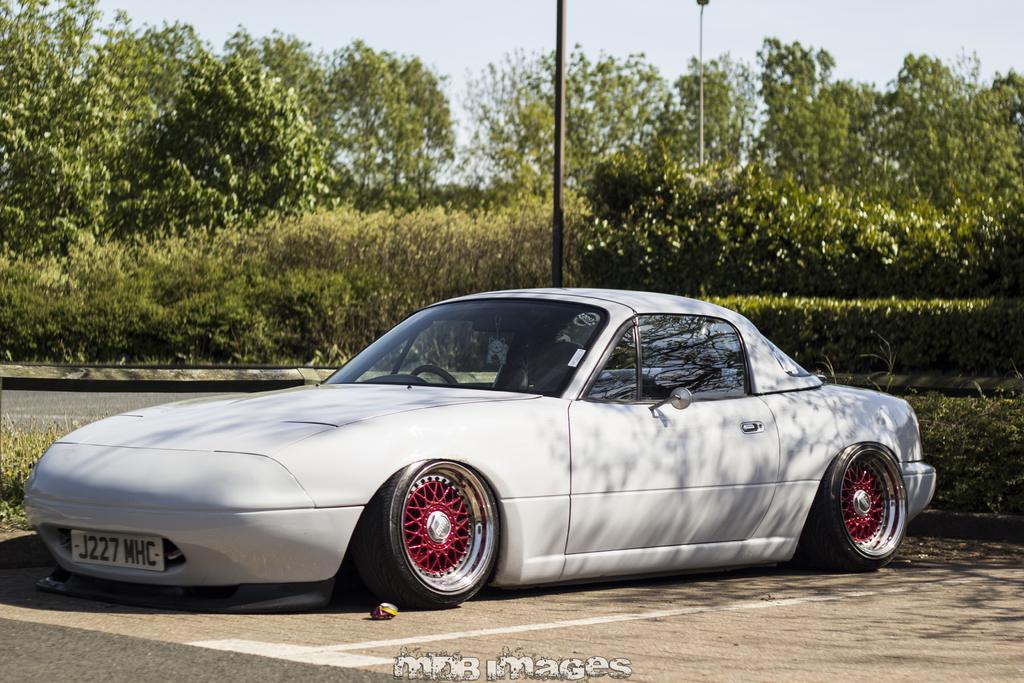Describe this image in one or two sentences. In this picture there is a white car on the road. At the back there are trees and poles and there is a railing. At the top there is sky. At the bottom there is a road and there is text. 